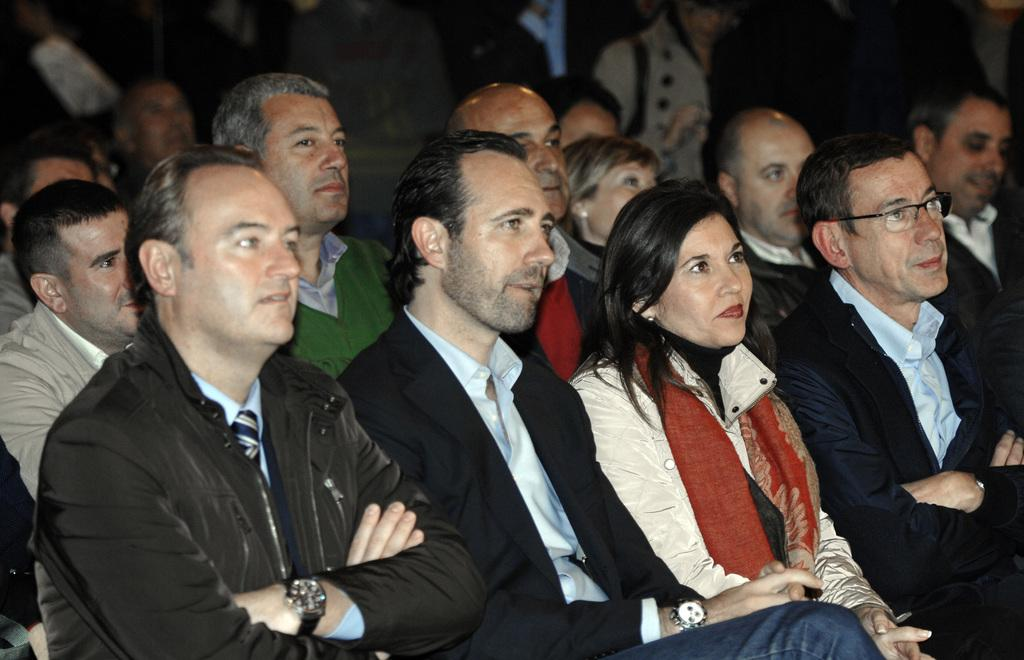How many people are in the image? There are multiple persons in the image. Can you describe the seating arrangement of the people in the image? Three men are sitting in the front, and a woman is sitting with the men. What does the smell of the quarter in the image indicate? There is no mention of a quarter or any smell in the image, so this question cannot be answered. 